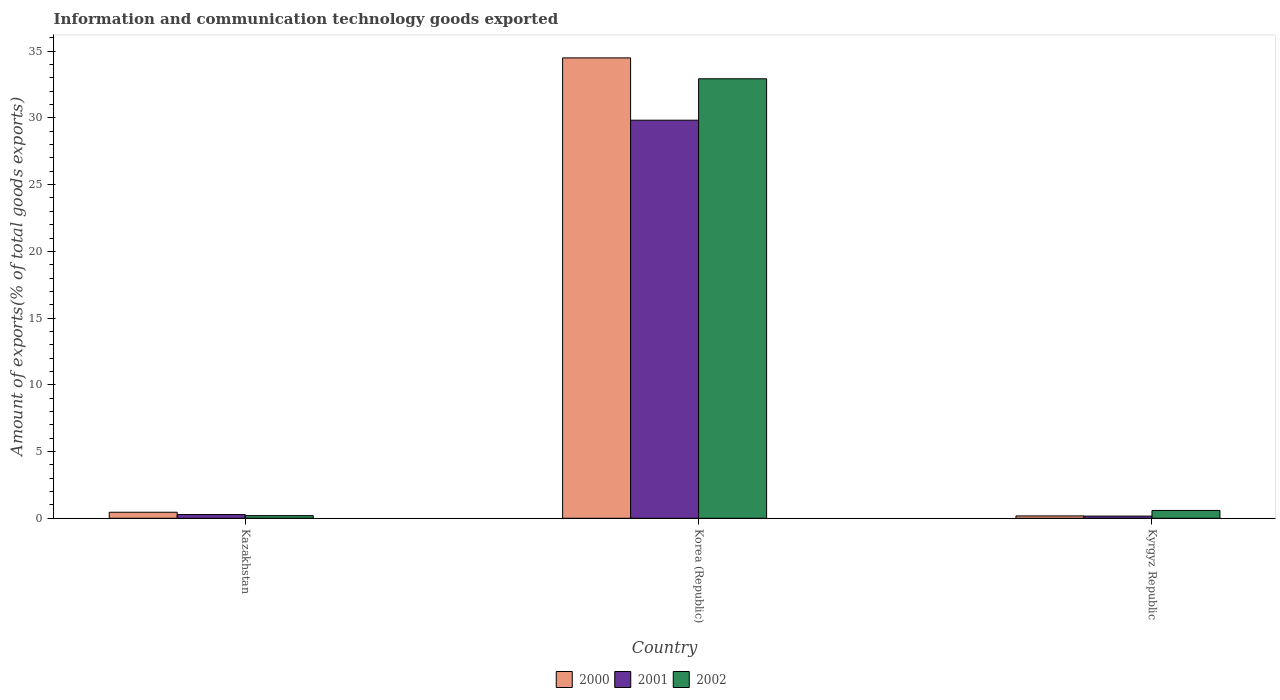How many different coloured bars are there?
Give a very brief answer. 3. How many bars are there on the 3rd tick from the left?
Keep it short and to the point. 3. What is the label of the 2nd group of bars from the left?
Offer a very short reply. Korea (Republic). What is the amount of goods exported in 2002 in Kyrgyz Republic?
Keep it short and to the point. 0.59. Across all countries, what is the maximum amount of goods exported in 2000?
Your response must be concise. 34.5. Across all countries, what is the minimum amount of goods exported in 2001?
Make the answer very short. 0.16. In which country was the amount of goods exported in 2001 minimum?
Offer a very short reply. Kyrgyz Republic. What is the total amount of goods exported in 2001 in the graph?
Your response must be concise. 30.27. What is the difference between the amount of goods exported in 2000 in Kazakhstan and that in Kyrgyz Republic?
Provide a short and direct response. 0.28. What is the difference between the amount of goods exported in 2001 in Kazakhstan and the amount of goods exported in 2002 in Korea (Republic)?
Provide a short and direct response. -32.65. What is the average amount of goods exported in 2002 per country?
Offer a very short reply. 11.24. What is the difference between the amount of goods exported of/in 2001 and amount of goods exported of/in 2002 in Korea (Republic)?
Keep it short and to the point. -3.1. What is the ratio of the amount of goods exported in 2001 in Kazakhstan to that in Kyrgyz Republic?
Your answer should be compact. 1.72. Is the amount of goods exported in 2001 in Korea (Republic) less than that in Kyrgyz Republic?
Offer a terse response. No. What is the difference between the highest and the second highest amount of goods exported in 2001?
Give a very brief answer. 0.12. What is the difference between the highest and the lowest amount of goods exported in 2002?
Provide a succinct answer. 32.73. In how many countries, is the amount of goods exported in 2002 greater than the average amount of goods exported in 2002 taken over all countries?
Your answer should be compact. 1. Is the sum of the amount of goods exported in 2002 in Kazakhstan and Korea (Republic) greater than the maximum amount of goods exported in 2000 across all countries?
Ensure brevity in your answer.  No. What does the 3rd bar from the left in Kyrgyz Republic represents?
Keep it short and to the point. 2002. How many bars are there?
Provide a short and direct response. 9. Are all the bars in the graph horizontal?
Offer a terse response. No. Does the graph contain grids?
Your response must be concise. No. How many legend labels are there?
Offer a terse response. 3. What is the title of the graph?
Keep it short and to the point. Information and communication technology goods exported. What is the label or title of the Y-axis?
Your response must be concise. Amount of exports(% of total goods exports). What is the Amount of exports(% of total goods exports) in 2000 in Kazakhstan?
Your response must be concise. 0.45. What is the Amount of exports(% of total goods exports) in 2001 in Kazakhstan?
Make the answer very short. 0.28. What is the Amount of exports(% of total goods exports) of 2002 in Kazakhstan?
Offer a terse response. 0.2. What is the Amount of exports(% of total goods exports) in 2000 in Korea (Republic)?
Give a very brief answer. 34.5. What is the Amount of exports(% of total goods exports) in 2001 in Korea (Republic)?
Provide a succinct answer. 29.83. What is the Amount of exports(% of total goods exports) of 2002 in Korea (Republic)?
Make the answer very short. 32.93. What is the Amount of exports(% of total goods exports) of 2000 in Kyrgyz Republic?
Provide a short and direct response. 0.18. What is the Amount of exports(% of total goods exports) in 2001 in Kyrgyz Republic?
Your response must be concise. 0.16. What is the Amount of exports(% of total goods exports) of 2002 in Kyrgyz Republic?
Make the answer very short. 0.59. Across all countries, what is the maximum Amount of exports(% of total goods exports) of 2000?
Provide a short and direct response. 34.5. Across all countries, what is the maximum Amount of exports(% of total goods exports) of 2001?
Give a very brief answer. 29.83. Across all countries, what is the maximum Amount of exports(% of total goods exports) of 2002?
Offer a terse response. 32.93. Across all countries, what is the minimum Amount of exports(% of total goods exports) of 2000?
Provide a succinct answer. 0.18. Across all countries, what is the minimum Amount of exports(% of total goods exports) of 2001?
Give a very brief answer. 0.16. Across all countries, what is the minimum Amount of exports(% of total goods exports) in 2002?
Provide a short and direct response. 0.2. What is the total Amount of exports(% of total goods exports) of 2000 in the graph?
Your answer should be very brief. 35.12. What is the total Amount of exports(% of total goods exports) in 2001 in the graph?
Your answer should be very brief. 30.27. What is the total Amount of exports(% of total goods exports) of 2002 in the graph?
Give a very brief answer. 33.72. What is the difference between the Amount of exports(% of total goods exports) of 2000 in Kazakhstan and that in Korea (Republic)?
Provide a succinct answer. -34.04. What is the difference between the Amount of exports(% of total goods exports) in 2001 in Kazakhstan and that in Korea (Republic)?
Make the answer very short. -29.55. What is the difference between the Amount of exports(% of total goods exports) of 2002 in Kazakhstan and that in Korea (Republic)?
Your answer should be compact. -32.73. What is the difference between the Amount of exports(% of total goods exports) in 2000 in Kazakhstan and that in Kyrgyz Republic?
Offer a very short reply. 0.28. What is the difference between the Amount of exports(% of total goods exports) in 2001 in Kazakhstan and that in Kyrgyz Republic?
Your answer should be compact. 0.12. What is the difference between the Amount of exports(% of total goods exports) of 2002 in Kazakhstan and that in Kyrgyz Republic?
Ensure brevity in your answer.  -0.39. What is the difference between the Amount of exports(% of total goods exports) in 2000 in Korea (Republic) and that in Kyrgyz Republic?
Offer a terse response. 34.32. What is the difference between the Amount of exports(% of total goods exports) in 2001 in Korea (Republic) and that in Kyrgyz Republic?
Ensure brevity in your answer.  29.67. What is the difference between the Amount of exports(% of total goods exports) in 2002 in Korea (Republic) and that in Kyrgyz Republic?
Your response must be concise. 32.34. What is the difference between the Amount of exports(% of total goods exports) in 2000 in Kazakhstan and the Amount of exports(% of total goods exports) in 2001 in Korea (Republic)?
Offer a very short reply. -29.38. What is the difference between the Amount of exports(% of total goods exports) in 2000 in Kazakhstan and the Amount of exports(% of total goods exports) in 2002 in Korea (Republic)?
Give a very brief answer. -32.48. What is the difference between the Amount of exports(% of total goods exports) in 2001 in Kazakhstan and the Amount of exports(% of total goods exports) in 2002 in Korea (Republic)?
Provide a succinct answer. -32.65. What is the difference between the Amount of exports(% of total goods exports) of 2000 in Kazakhstan and the Amount of exports(% of total goods exports) of 2001 in Kyrgyz Republic?
Your response must be concise. 0.29. What is the difference between the Amount of exports(% of total goods exports) of 2000 in Kazakhstan and the Amount of exports(% of total goods exports) of 2002 in Kyrgyz Republic?
Offer a very short reply. -0.13. What is the difference between the Amount of exports(% of total goods exports) of 2001 in Kazakhstan and the Amount of exports(% of total goods exports) of 2002 in Kyrgyz Republic?
Provide a short and direct response. -0.31. What is the difference between the Amount of exports(% of total goods exports) in 2000 in Korea (Republic) and the Amount of exports(% of total goods exports) in 2001 in Kyrgyz Republic?
Make the answer very short. 34.33. What is the difference between the Amount of exports(% of total goods exports) in 2000 in Korea (Republic) and the Amount of exports(% of total goods exports) in 2002 in Kyrgyz Republic?
Offer a very short reply. 33.91. What is the difference between the Amount of exports(% of total goods exports) of 2001 in Korea (Republic) and the Amount of exports(% of total goods exports) of 2002 in Kyrgyz Republic?
Your answer should be compact. 29.24. What is the average Amount of exports(% of total goods exports) in 2000 per country?
Make the answer very short. 11.71. What is the average Amount of exports(% of total goods exports) of 2001 per country?
Provide a short and direct response. 10.09. What is the average Amount of exports(% of total goods exports) of 2002 per country?
Make the answer very short. 11.24. What is the difference between the Amount of exports(% of total goods exports) of 2000 and Amount of exports(% of total goods exports) of 2001 in Kazakhstan?
Provide a short and direct response. 0.17. What is the difference between the Amount of exports(% of total goods exports) of 2000 and Amount of exports(% of total goods exports) of 2002 in Kazakhstan?
Offer a terse response. 0.25. What is the difference between the Amount of exports(% of total goods exports) of 2001 and Amount of exports(% of total goods exports) of 2002 in Kazakhstan?
Make the answer very short. 0.08. What is the difference between the Amount of exports(% of total goods exports) in 2000 and Amount of exports(% of total goods exports) in 2001 in Korea (Republic)?
Your answer should be very brief. 4.67. What is the difference between the Amount of exports(% of total goods exports) of 2000 and Amount of exports(% of total goods exports) of 2002 in Korea (Republic)?
Keep it short and to the point. 1.57. What is the difference between the Amount of exports(% of total goods exports) of 2001 and Amount of exports(% of total goods exports) of 2002 in Korea (Republic)?
Make the answer very short. -3.1. What is the difference between the Amount of exports(% of total goods exports) of 2000 and Amount of exports(% of total goods exports) of 2001 in Kyrgyz Republic?
Offer a very short reply. 0.01. What is the difference between the Amount of exports(% of total goods exports) of 2000 and Amount of exports(% of total goods exports) of 2002 in Kyrgyz Republic?
Offer a terse response. -0.41. What is the difference between the Amount of exports(% of total goods exports) in 2001 and Amount of exports(% of total goods exports) in 2002 in Kyrgyz Republic?
Ensure brevity in your answer.  -0.42. What is the ratio of the Amount of exports(% of total goods exports) of 2000 in Kazakhstan to that in Korea (Republic)?
Your response must be concise. 0.01. What is the ratio of the Amount of exports(% of total goods exports) of 2001 in Kazakhstan to that in Korea (Republic)?
Offer a very short reply. 0.01. What is the ratio of the Amount of exports(% of total goods exports) in 2002 in Kazakhstan to that in Korea (Republic)?
Keep it short and to the point. 0.01. What is the ratio of the Amount of exports(% of total goods exports) of 2000 in Kazakhstan to that in Kyrgyz Republic?
Ensure brevity in your answer.  2.56. What is the ratio of the Amount of exports(% of total goods exports) in 2001 in Kazakhstan to that in Kyrgyz Republic?
Provide a short and direct response. 1.72. What is the ratio of the Amount of exports(% of total goods exports) in 2002 in Kazakhstan to that in Kyrgyz Republic?
Provide a succinct answer. 0.34. What is the ratio of the Amount of exports(% of total goods exports) of 2000 in Korea (Republic) to that in Kyrgyz Republic?
Give a very brief answer. 195.36. What is the ratio of the Amount of exports(% of total goods exports) in 2001 in Korea (Republic) to that in Kyrgyz Republic?
Offer a terse response. 183.52. What is the ratio of the Amount of exports(% of total goods exports) of 2002 in Korea (Republic) to that in Kyrgyz Republic?
Your answer should be compact. 56.21. What is the difference between the highest and the second highest Amount of exports(% of total goods exports) in 2000?
Provide a short and direct response. 34.04. What is the difference between the highest and the second highest Amount of exports(% of total goods exports) in 2001?
Your response must be concise. 29.55. What is the difference between the highest and the second highest Amount of exports(% of total goods exports) in 2002?
Your answer should be compact. 32.34. What is the difference between the highest and the lowest Amount of exports(% of total goods exports) of 2000?
Your answer should be compact. 34.32. What is the difference between the highest and the lowest Amount of exports(% of total goods exports) in 2001?
Offer a terse response. 29.67. What is the difference between the highest and the lowest Amount of exports(% of total goods exports) in 2002?
Your answer should be very brief. 32.73. 